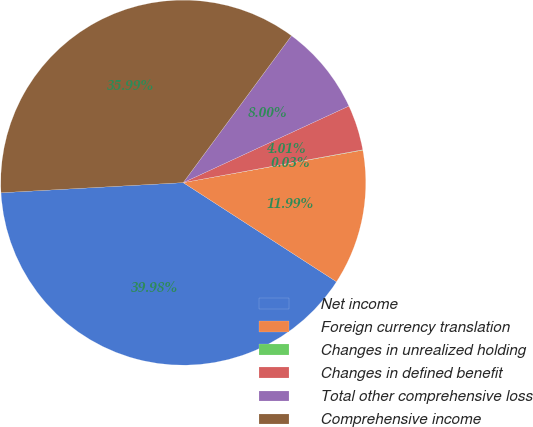Convert chart to OTSL. <chart><loc_0><loc_0><loc_500><loc_500><pie_chart><fcel>Net income<fcel>Foreign currency translation<fcel>Changes in unrealized holding<fcel>Changes in defined benefit<fcel>Total other comprehensive loss<fcel>Comprehensive income<nl><fcel>39.98%<fcel>11.99%<fcel>0.03%<fcel>4.01%<fcel>8.0%<fcel>35.99%<nl></chart> 